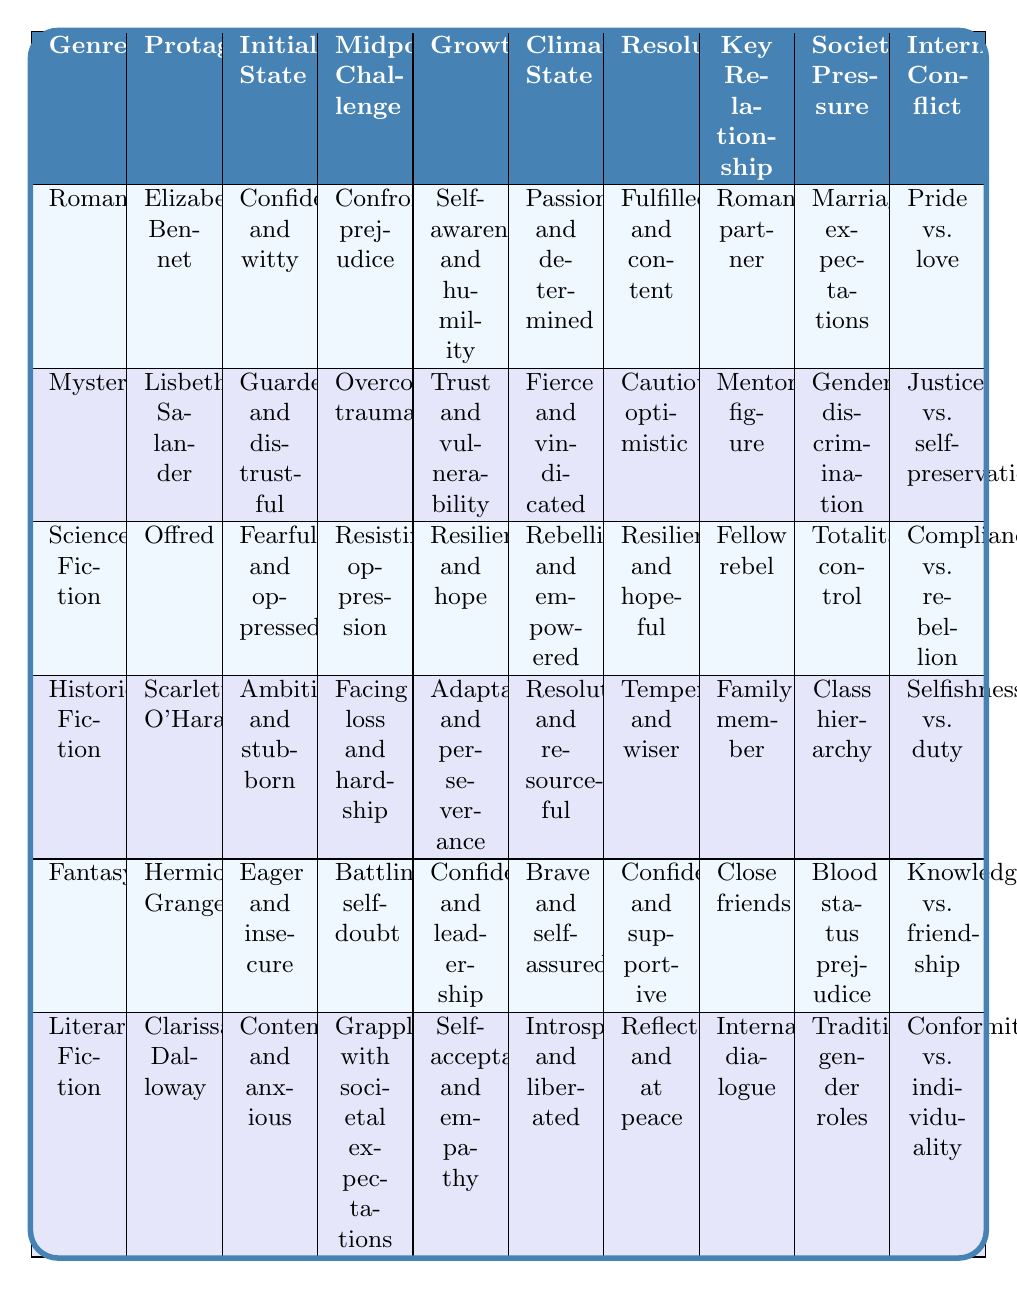What is the initial emotional state of Elizabeth Bennet? Referring to the table, Elizabeth Bennet's initial emotional state is listed as "Confident and witty."
Answer: Confident and witty Which protagonist experiences resilience and hope as their character growth? By scanning the table, the protagonist who experiences resilience and hope as their character growth is Offred from the Science Fiction genre.
Answer: Offred Is Scarlett O'Hara's resolution emotional outcome tempered and wiser? Looking at the table, Scarlett O'Hara's resolution emotional outcome is stated as "Tempered and wiser," confirming the answer is yes.
Answer: Yes What do both Lisbeth Salander and Hermione Granger's key relationships have in common? Both Lisbeth Salander and Hermione Granger's key relationships involve significant figures: Salander's is a mentor figure, and Granger's is close friends. This suggests their growth is influenced by trustworthy connections, common in characters navigating challenges.
Answer: Significant relationships impact their growth Which genre has a protagonist that is fearful and oppressed at the start? Checking the table, the genre that features a protagonist described as fearful and oppressed initially is Science Fiction, specifically Offred.
Answer: Science Fiction How many protagonists have their emotional climax state as introspective and liberated? The table indicates that only one protagonist, Clarissa Dalloway, has an emotional climax state of introspective and liberated, as shown in the Literary Fiction genre.
Answer: One protagonist What is the societal pressure influence faced by Elizabeth Bennet? According to the table, Elizabeth Bennet faces societal pressure in the form of marriage expectations, as shown in the Romance genre.
Answer: Marriage expectations What emotional challenge does Hermione Granger confront at the midpoint of her story? In the table, Hermione Granger confronts the challenge of battling self-doubt in the Fantasy genre at the midpoint.
Answer: Battling self-doubt Which genres feature protagonists whose characters grow into self-acceptance and empathy? Reviewing the table, only Clarissa Dalloway in Literary Fiction experiences growth into self-acceptance and empathy, highlighting the uniqueness of her journey compared to others.
Answer: Literary Fiction Are there more protagonists characterized by confidence in their initial emotional state than those characterized by fearfulness? The table shows that two protagonists (Elizabeth Bennet and Hermione Granger) have confidence, while only one (Offred) is characterized by fearfulness, suggesting more confident protagonists.
Answer: Yes Who has a key relationship influence focused on internal dialogue, and what is their initial emotional state? Clarissa Dalloway has a key relationship influence focused on internal dialogue, and her initial emotional state is contemplative and anxious, as per the table.
Answer: Clarissa Dalloway; contemplative and anxious 